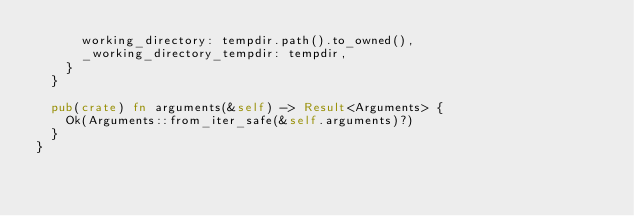<code> <loc_0><loc_0><loc_500><loc_500><_Rust_>      working_directory: tempdir.path().to_owned(),
      _working_directory_tempdir: tempdir,
    }
  }

  pub(crate) fn arguments(&self) -> Result<Arguments> {
    Ok(Arguments::from_iter_safe(&self.arguments)?)
  }
}
</code> 